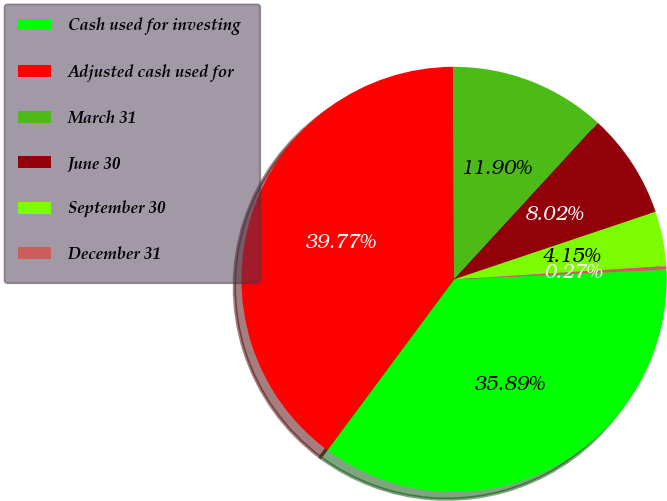<chart> <loc_0><loc_0><loc_500><loc_500><pie_chart><fcel>Cash used for investing<fcel>Adjusted cash used for<fcel>March 31<fcel>June 30<fcel>September 30<fcel>December 31<nl><fcel>35.89%<fcel>39.77%<fcel>11.9%<fcel>8.02%<fcel>4.15%<fcel>0.27%<nl></chart> 